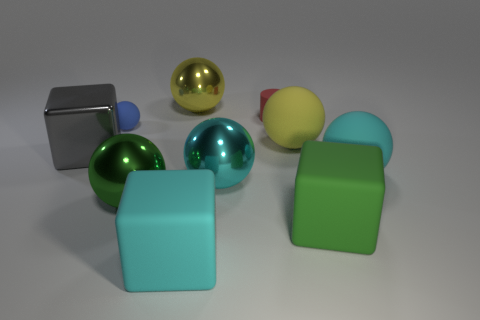Subtract all green balls. How many balls are left? 5 Subtract all large green balls. How many balls are left? 5 Subtract all green balls. Subtract all brown cubes. How many balls are left? 5 Subtract all cylinders. How many objects are left? 9 Add 1 small gray rubber objects. How many small gray rubber objects exist? 1 Subtract 1 red cylinders. How many objects are left? 9 Subtract all big green metallic spheres. Subtract all green matte cubes. How many objects are left? 8 Add 2 rubber things. How many rubber things are left? 8 